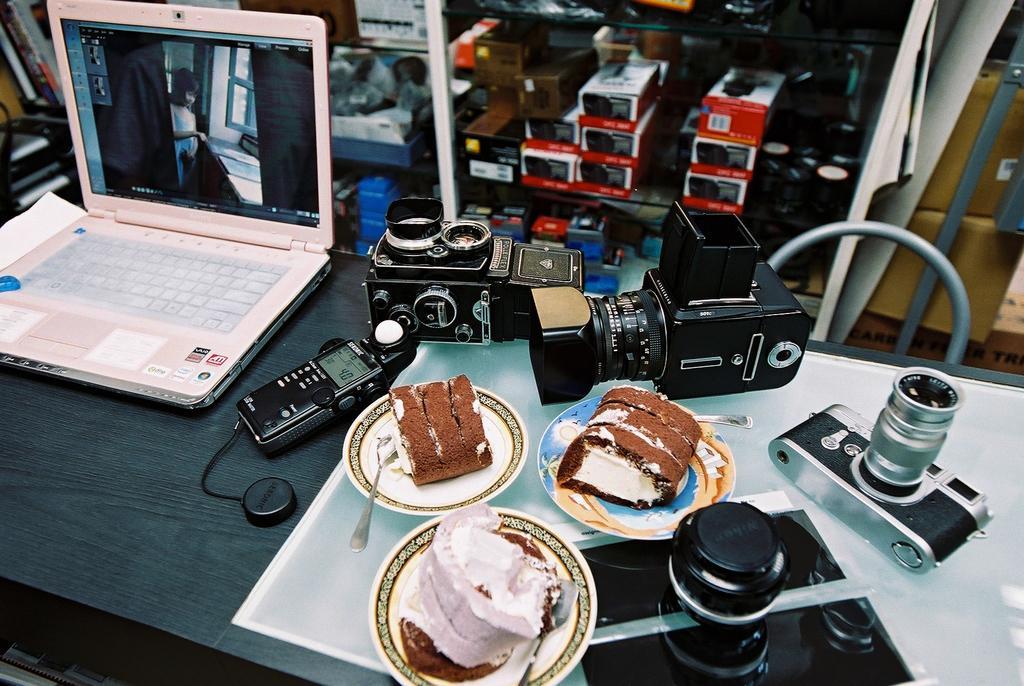Can you describe this image briefly? We can see laptop, telephone, cameras and a plate of pastries and spoon on the table. 